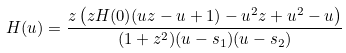<formula> <loc_0><loc_0><loc_500><loc_500>H ( u ) = \frac { z \left ( z H ( 0 ) ( u z - u + 1 ) - u ^ { 2 } z + u ^ { 2 } - u \right ) } { ( 1 + z ^ { 2 } ) ( u - s _ { 1 } ) ( u - s _ { 2 } ) }</formula> 